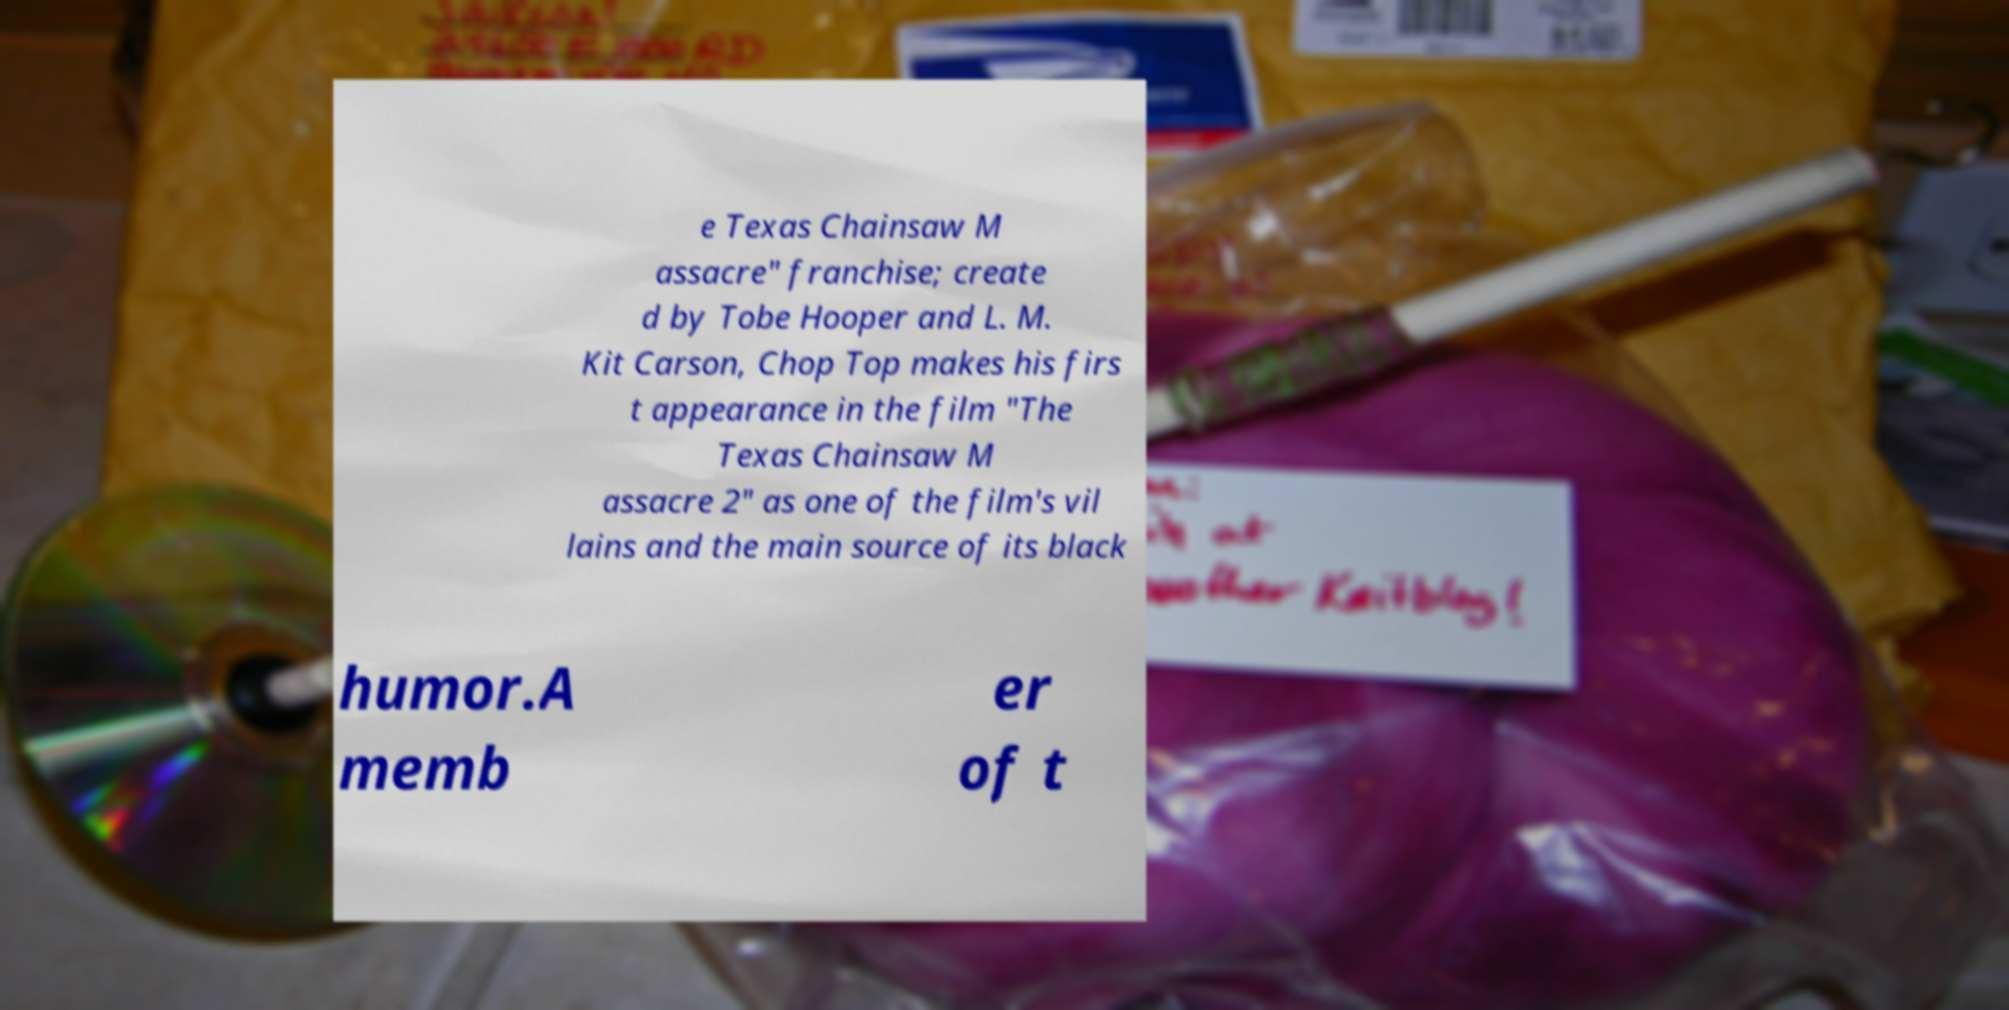Could you extract and type out the text from this image? e Texas Chainsaw M assacre" franchise; create d by Tobe Hooper and L. M. Kit Carson, Chop Top makes his firs t appearance in the film "The Texas Chainsaw M assacre 2" as one of the film's vil lains and the main source of its black humor.A memb er of t 